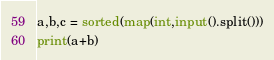<code> <loc_0><loc_0><loc_500><loc_500><_Python_>a,b,c = sorted(map(int,input().split()))
print(a+b)</code> 